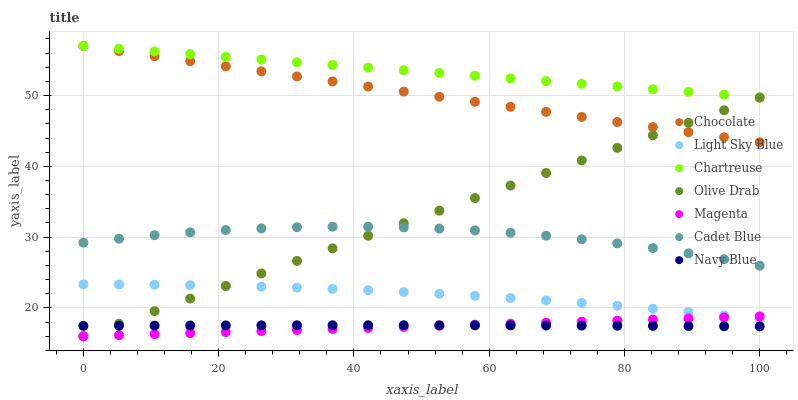Does Magenta have the minimum area under the curve?
Answer yes or no. Yes. Does Chartreuse have the maximum area under the curve?
Answer yes or no. Yes. Does Navy Blue have the minimum area under the curve?
Answer yes or no. No. Does Navy Blue have the maximum area under the curve?
Answer yes or no. No. Is Olive Drab the smoothest?
Answer yes or no. Yes. Is Cadet Blue the roughest?
Answer yes or no. Yes. Is Navy Blue the smoothest?
Answer yes or no. No. Is Navy Blue the roughest?
Answer yes or no. No. Does Magenta have the lowest value?
Answer yes or no. Yes. Does Navy Blue have the lowest value?
Answer yes or no. No. Does Chartreuse have the highest value?
Answer yes or no. Yes. Does Navy Blue have the highest value?
Answer yes or no. No. Is Olive Drab less than Chartreuse?
Answer yes or no. Yes. Is Light Sky Blue greater than Navy Blue?
Answer yes or no. Yes. Does Olive Drab intersect Navy Blue?
Answer yes or no. Yes. Is Olive Drab less than Navy Blue?
Answer yes or no. No. Is Olive Drab greater than Navy Blue?
Answer yes or no. No. Does Olive Drab intersect Chartreuse?
Answer yes or no. No. 